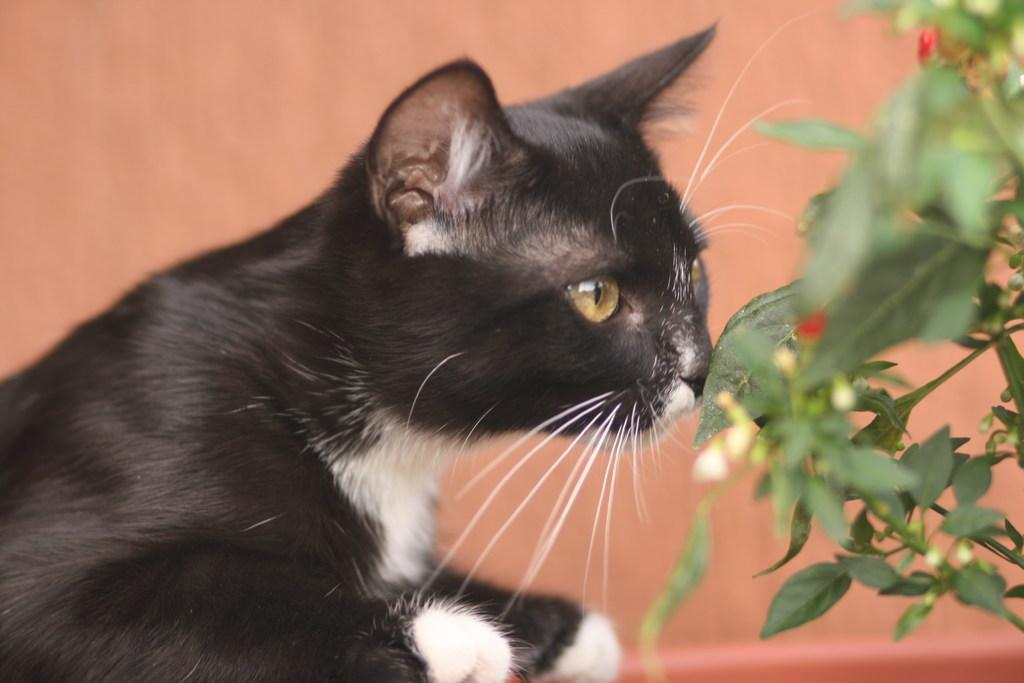What type of animal is in the image? There is a cat in the image. What natural elements can be seen in the image? Leaves are visible in the image. How would you describe the background color of the image? The background of the image has a peach color. What type of battle is taking place in the image? There is no battle present in the image; it features a cat and leaves with a peach-colored background. 